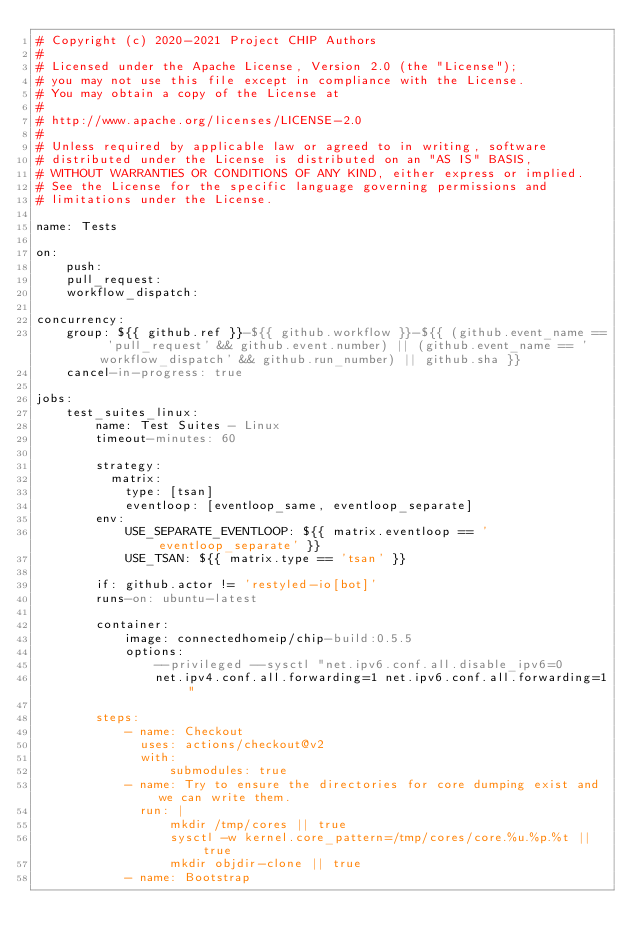Convert code to text. <code><loc_0><loc_0><loc_500><loc_500><_YAML_># Copyright (c) 2020-2021 Project CHIP Authors
#
# Licensed under the Apache License, Version 2.0 (the "License");
# you may not use this file except in compliance with the License.
# You may obtain a copy of the License at
#
# http://www.apache.org/licenses/LICENSE-2.0
#
# Unless required by applicable law or agreed to in writing, software
# distributed under the License is distributed on an "AS IS" BASIS,
# WITHOUT WARRANTIES OR CONDITIONS OF ANY KIND, either express or implied.
# See the License for the specific language governing permissions and
# limitations under the License.

name: Tests

on:
    push:
    pull_request:
    workflow_dispatch:

concurrency:
    group: ${{ github.ref }}-${{ github.workflow }}-${{ (github.event_name == 'pull_request' && github.event.number) || (github.event_name == 'workflow_dispatch' && github.run_number) || github.sha }}
    cancel-in-progress: true

jobs:
    test_suites_linux:
        name: Test Suites - Linux
        timeout-minutes: 60

        strategy:
          matrix:
            type: [tsan]
            eventloop: [eventloop_same, eventloop_separate]
        env:
            USE_SEPARATE_EVENTLOOP: ${{ matrix.eventloop == 'eventloop_separate' }}
            USE_TSAN: ${{ matrix.type == 'tsan' }}

        if: github.actor != 'restyled-io[bot]'
        runs-on: ubuntu-latest

        container:
            image: connectedhomeip/chip-build:0.5.5
            options:
                --privileged --sysctl "net.ipv6.conf.all.disable_ipv6=0
                net.ipv4.conf.all.forwarding=1 net.ipv6.conf.all.forwarding=1"

        steps:
            - name: Checkout
              uses: actions/checkout@v2
              with:
                  submodules: true
            - name: Try to ensure the directories for core dumping exist and we can write them.
              run: |
                  mkdir /tmp/cores || true
                  sysctl -w kernel.core_pattern=/tmp/cores/core.%u.%p.%t || true
                  mkdir objdir-clone || true
            - name: Bootstrap</code> 